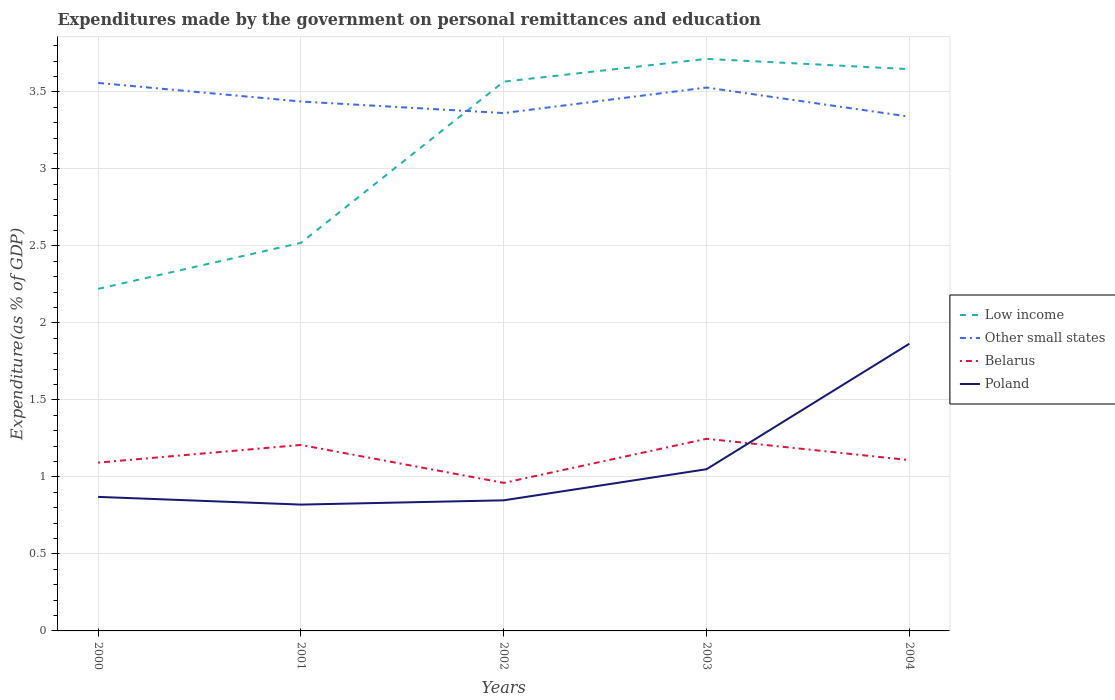How many different coloured lines are there?
Give a very brief answer. 4. Does the line corresponding to Other small states intersect with the line corresponding to Belarus?
Offer a very short reply. No. Is the number of lines equal to the number of legend labels?
Your response must be concise. Yes. Across all years, what is the maximum expenditures made by the government on personal remittances and education in Poland?
Offer a very short reply. 0.82. In which year was the expenditures made by the government on personal remittances and education in Poland maximum?
Provide a succinct answer. 2001. What is the total expenditures made by the government on personal remittances and education in Other small states in the graph?
Offer a terse response. 0.22. What is the difference between the highest and the second highest expenditures made by the government on personal remittances and education in Belarus?
Your answer should be compact. 0.29. What is the difference between the highest and the lowest expenditures made by the government on personal remittances and education in Poland?
Give a very brief answer. 1. How many lines are there?
Your answer should be compact. 4. How many years are there in the graph?
Your answer should be very brief. 5. What is the difference between two consecutive major ticks on the Y-axis?
Make the answer very short. 0.5. Where does the legend appear in the graph?
Provide a succinct answer. Center right. What is the title of the graph?
Give a very brief answer. Expenditures made by the government on personal remittances and education. Does "Morocco" appear as one of the legend labels in the graph?
Your answer should be compact. No. What is the label or title of the X-axis?
Offer a terse response. Years. What is the label or title of the Y-axis?
Keep it short and to the point. Expenditure(as % of GDP). What is the Expenditure(as % of GDP) in Low income in 2000?
Give a very brief answer. 2.22. What is the Expenditure(as % of GDP) of Other small states in 2000?
Offer a very short reply. 3.56. What is the Expenditure(as % of GDP) of Belarus in 2000?
Give a very brief answer. 1.09. What is the Expenditure(as % of GDP) in Poland in 2000?
Your response must be concise. 0.87. What is the Expenditure(as % of GDP) in Low income in 2001?
Make the answer very short. 2.52. What is the Expenditure(as % of GDP) of Other small states in 2001?
Make the answer very short. 3.44. What is the Expenditure(as % of GDP) in Belarus in 2001?
Your answer should be compact. 1.21. What is the Expenditure(as % of GDP) in Poland in 2001?
Ensure brevity in your answer.  0.82. What is the Expenditure(as % of GDP) in Low income in 2002?
Your answer should be compact. 3.57. What is the Expenditure(as % of GDP) in Other small states in 2002?
Your response must be concise. 3.36. What is the Expenditure(as % of GDP) in Belarus in 2002?
Your answer should be very brief. 0.96. What is the Expenditure(as % of GDP) of Poland in 2002?
Your answer should be very brief. 0.85. What is the Expenditure(as % of GDP) in Low income in 2003?
Your response must be concise. 3.71. What is the Expenditure(as % of GDP) in Other small states in 2003?
Offer a very short reply. 3.53. What is the Expenditure(as % of GDP) in Belarus in 2003?
Your answer should be very brief. 1.25. What is the Expenditure(as % of GDP) of Poland in 2003?
Offer a terse response. 1.05. What is the Expenditure(as % of GDP) in Low income in 2004?
Give a very brief answer. 3.65. What is the Expenditure(as % of GDP) of Other small states in 2004?
Your response must be concise. 3.34. What is the Expenditure(as % of GDP) in Belarus in 2004?
Make the answer very short. 1.11. What is the Expenditure(as % of GDP) in Poland in 2004?
Ensure brevity in your answer.  1.86. Across all years, what is the maximum Expenditure(as % of GDP) in Low income?
Offer a terse response. 3.71. Across all years, what is the maximum Expenditure(as % of GDP) in Other small states?
Your answer should be compact. 3.56. Across all years, what is the maximum Expenditure(as % of GDP) of Belarus?
Make the answer very short. 1.25. Across all years, what is the maximum Expenditure(as % of GDP) of Poland?
Keep it short and to the point. 1.86. Across all years, what is the minimum Expenditure(as % of GDP) in Low income?
Provide a short and direct response. 2.22. Across all years, what is the minimum Expenditure(as % of GDP) of Other small states?
Your answer should be very brief. 3.34. Across all years, what is the minimum Expenditure(as % of GDP) in Belarus?
Offer a very short reply. 0.96. Across all years, what is the minimum Expenditure(as % of GDP) in Poland?
Your answer should be compact. 0.82. What is the total Expenditure(as % of GDP) in Low income in the graph?
Your answer should be very brief. 15.67. What is the total Expenditure(as % of GDP) of Other small states in the graph?
Provide a short and direct response. 17.23. What is the total Expenditure(as % of GDP) in Belarus in the graph?
Your answer should be very brief. 5.62. What is the total Expenditure(as % of GDP) in Poland in the graph?
Provide a short and direct response. 5.45. What is the difference between the Expenditure(as % of GDP) in Low income in 2000 and that in 2001?
Your answer should be very brief. -0.3. What is the difference between the Expenditure(as % of GDP) of Other small states in 2000 and that in 2001?
Ensure brevity in your answer.  0.12. What is the difference between the Expenditure(as % of GDP) of Belarus in 2000 and that in 2001?
Your answer should be very brief. -0.11. What is the difference between the Expenditure(as % of GDP) in Low income in 2000 and that in 2002?
Make the answer very short. -1.35. What is the difference between the Expenditure(as % of GDP) in Other small states in 2000 and that in 2002?
Provide a succinct answer. 0.2. What is the difference between the Expenditure(as % of GDP) in Belarus in 2000 and that in 2002?
Offer a very short reply. 0.13. What is the difference between the Expenditure(as % of GDP) in Poland in 2000 and that in 2002?
Offer a very short reply. 0.02. What is the difference between the Expenditure(as % of GDP) in Low income in 2000 and that in 2003?
Your response must be concise. -1.49. What is the difference between the Expenditure(as % of GDP) in Other small states in 2000 and that in 2003?
Provide a short and direct response. 0.03. What is the difference between the Expenditure(as % of GDP) of Belarus in 2000 and that in 2003?
Provide a short and direct response. -0.15. What is the difference between the Expenditure(as % of GDP) of Poland in 2000 and that in 2003?
Your answer should be very brief. -0.18. What is the difference between the Expenditure(as % of GDP) in Low income in 2000 and that in 2004?
Your response must be concise. -1.43. What is the difference between the Expenditure(as % of GDP) of Other small states in 2000 and that in 2004?
Provide a succinct answer. 0.22. What is the difference between the Expenditure(as % of GDP) of Belarus in 2000 and that in 2004?
Make the answer very short. -0.02. What is the difference between the Expenditure(as % of GDP) in Poland in 2000 and that in 2004?
Give a very brief answer. -0.99. What is the difference between the Expenditure(as % of GDP) in Low income in 2001 and that in 2002?
Your answer should be very brief. -1.05. What is the difference between the Expenditure(as % of GDP) of Other small states in 2001 and that in 2002?
Provide a short and direct response. 0.08. What is the difference between the Expenditure(as % of GDP) in Belarus in 2001 and that in 2002?
Your response must be concise. 0.25. What is the difference between the Expenditure(as % of GDP) of Poland in 2001 and that in 2002?
Your answer should be very brief. -0.03. What is the difference between the Expenditure(as % of GDP) of Low income in 2001 and that in 2003?
Make the answer very short. -1.19. What is the difference between the Expenditure(as % of GDP) of Other small states in 2001 and that in 2003?
Ensure brevity in your answer.  -0.09. What is the difference between the Expenditure(as % of GDP) in Belarus in 2001 and that in 2003?
Give a very brief answer. -0.04. What is the difference between the Expenditure(as % of GDP) of Poland in 2001 and that in 2003?
Provide a short and direct response. -0.23. What is the difference between the Expenditure(as % of GDP) in Low income in 2001 and that in 2004?
Your answer should be compact. -1.13. What is the difference between the Expenditure(as % of GDP) in Other small states in 2001 and that in 2004?
Your answer should be compact. 0.1. What is the difference between the Expenditure(as % of GDP) of Belarus in 2001 and that in 2004?
Your answer should be compact. 0.1. What is the difference between the Expenditure(as % of GDP) in Poland in 2001 and that in 2004?
Your answer should be very brief. -1.04. What is the difference between the Expenditure(as % of GDP) of Low income in 2002 and that in 2003?
Make the answer very short. -0.15. What is the difference between the Expenditure(as % of GDP) of Other small states in 2002 and that in 2003?
Give a very brief answer. -0.17. What is the difference between the Expenditure(as % of GDP) in Belarus in 2002 and that in 2003?
Offer a very short reply. -0.29. What is the difference between the Expenditure(as % of GDP) in Poland in 2002 and that in 2003?
Your answer should be very brief. -0.2. What is the difference between the Expenditure(as % of GDP) of Low income in 2002 and that in 2004?
Offer a terse response. -0.08. What is the difference between the Expenditure(as % of GDP) in Other small states in 2002 and that in 2004?
Ensure brevity in your answer.  0.02. What is the difference between the Expenditure(as % of GDP) of Belarus in 2002 and that in 2004?
Give a very brief answer. -0.15. What is the difference between the Expenditure(as % of GDP) in Poland in 2002 and that in 2004?
Ensure brevity in your answer.  -1.02. What is the difference between the Expenditure(as % of GDP) of Low income in 2003 and that in 2004?
Provide a short and direct response. 0.07. What is the difference between the Expenditure(as % of GDP) of Other small states in 2003 and that in 2004?
Make the answer very short. 0.19. What is the difference between the Expenditure(as % of GDP) of Belarus in 2003 and that in 2004?
Offer a terse response. 0.14. What is the difference between the Expenditure(as % of GDP) in Poland in 2003 and that in 2004?
Provide a succinct answer. -0.81. What is the difference between the Expenditure(as % of GDP) of Low income in 2000 and the Expenditure(as % of GDP) of Other small states in 2001?
Keep it short and to the point. -1.22. What is the difference between the Expenditure(as % of GDP) of Low income in 2000 and the Expenditure(as % of GDP) of Belarus in 2001?
Your answer should be very brief. 1.01. What is the difference between the Expenditure(as % of GDP) of Low income in 2000 and the Expenditure(as % of GDP) of Poland in 2001?
Keep it short and to the point. 1.4. What is the difference between the Expenditure(as % of GDP) in Other small states in 2000 and the Expenditure(as % of GDP) in Belarus in 2001?
Give a very brief answer. 2.35. What is the difference between the Expenditure(as % of GDP) in Other small states in 2000 and the Expenditure(as % of GDP) in Poland in 2001?
Ensure brevity in your answer.  2.74. What is the difference between the Expenditure(as % of GDP) of Belarus in 2000 and the Expenditure(as % of GDP) of Poland in 2001?
Your response must be concise. 0.27. What is the difference between the Expenditure(as % of GDP) in Low income in 2000 and the Expenditure(as % of GDP) in Other small states in 2002?
Your response must be concise. -1.14. What is the difference between the Expenditure(as % of GDP) in Low income in 2000 and the Expenditure(as % of GDP) in Belarus in 2002?
Give a very brief answer. 1.26. What is the difference between the Expenditure(as % of GDP) in Low income in 2000 and the Expenditure(as % of GDP) in Poland in 2002?
Provide a succinct answer. 1.37. What is the difference between the Expenditure(as % of GDP) of Other small states in 2000 and the Expenditure(as % of GDP) of Belarus in 2002?
Ensure brevity in your answer.  2.6. What is the difference between the Expenditure(as % of GDP) of Other small states in 2000 and the Expenditure(as % of GDP) of Poland in 2002?
Keep it short and to the point. 2.71. What is the difference between the Expenditure(as % of GDP) in Belarus in 2000 and the Expenditure(as % of GDP) in Poland in 2002?
Your answer should be very brief. 0.24. What is the difference between the Expenditure(as % of GDP) in Low income in 2000 and the Expenditure(as % of GDP) in Other small states in 2003?
Keep it short and to the point. -1.31. What is the difference between the Expenditure(as % of GDP) in Low income in 2000 and the Expenditure(as % of GDP) in Belarus in 2003?
Your answer should be compact. 0.97. What is the difference between the Expenditure(as % of GDP) in Low income in 2000 and the Expenditure(as % of GDP) in Poland in 2003?
Provide a short and direct response. 1.17. What is the difference between the Expenditure(as % of GDP) in Other small states in 2000 and the Expenditure(as % of GDP) in Belarus in 2003?
Provide a succinct answer. 2.31. What is the difference between the Expenditure(as % of GDP) of Other small states in 2000 and the Expenditure(as % of GDP) of Poland in 2003?
Make the answer very short. 2.51. What is the difference between the Expenditure(as % of GDP) of Belarus in 2000 and the Expenditure(as % of GDP) of Poland in 2003?
Offer a very short reply. 0.04. What is the difference between the Expenditure(as % of GDP) of Low income in 2000 and the Expenditure(as % of GDP) of Other small states in 2004?
Provide a short and direct response. -1.12. What is the difference between the Expenditure(as % of GDP) in Low income in 2000 and the Expenditure(as % of GDP) in Belarus in 2004?
Provide a succinct answer. 1.11. What is the difference between the Expenditure(as % of GDP) of Low income in 2000 and the Expenditure(as % of GDP) of Poland in 2004?
Offer a terse response. 0.36. What is the difference between the Expenditure(as % of GDP) in Other small states in 2000 and the Expenditure(as % of GDP) in Belarus in 2004?
Your answer should be very brief. 2.45. What is the difference between the Expenditure(as % of GDP) of Other small states in 2000 and the Expenditure(as % of GDP) of Poland in 2004?
Your answer should be very brief. 1.69. What is the difference between the Expenditure(as % of GDP) in Belarus in 2000 and the Expenditure(as % of GDP) in Poland in 2004?
Offer a very short reply. -0.77. What is the difference between the Expenditure(as % of GDP) in Low income in 2001 and the Expenditure(as % of GDP) in Other small states in 2002?
Offer a very short reply. -0.84. What is the difference between the Expenditure(as % of GDP) in Low income in 2001 and the Expenditure(as % of GDP) in Belarus in 2002?
Your response must be concise. 1.56. What is the difference between the Expenditure(as % of GDP) of Low income in 2001 and the Expenditure(as % of GDP) of Poland in 2002?
Your answer should be very brief. 1.67. What is the difference between the Expenditure(as % of GDP) in Other small states in 2001 and the Expenditure(as % of GDP) in Belarus in 2002?
Keep it short and to the point. 2.48. What is the difference between the Expenditure(as % of GDP) of Other small states in 2001 and the Expenditure(as % of GDP) of Poland in 2002?
Your answer should be compact. 2.59. What is the difference between the Expenditure(as % of GDP) in Belarus in 2001 and the Expenditure(as % of GDP) in Poland in 2002?
Provide a short and direct response. 0.36. What is the difference between the Expenditure(as % of GDP) in Low income in 2001 and the Expenditure(as % of GDP) in Other small states in 2003?
Keep it short and to the point. -1.01. What is the difference between the Expenditure(as % of GDP) in Low income in 2001 and the Expenditure(as % of GDP) in Belarus in 2003?
Your answer should be compact. 1.27. What is the difference between the Expenditure(as % of GDP) in Low income in 2001 and the Expenditure(as % of GDP) in Poland in 2003?
Provide a succinct answer. 1.47. What is the difference between the Expenditure(as % of GDP) of Other small states in 2001 and the Expenditure(as % of GDP) of Belarus in 2003?
Provide a succinct answer. 2.19. What is the difference between the Expenditure(as % of GDP) in Other small states in 2001 and the Expenditure(as % of GDP) in Poland in 2003?
Provide a short and direct response. 2.39. What is the difference between the Expenditure(as % of GDP) of Belarus in 2001 and the Expenditure(as % of GDP) of Poland in 2003?
Offer a terse response. 0.16. What is the difference between the Expenditure(as % of GDP) of Low income in 2001 and the Expenditure(as % of GDP) of Other small states in 2004?
Your answer should be very brief. -0.82. What is the difference between the Expenditure(as % of GDP) in Low income in 2001 and the Expenditure(as % of GDP) in Belarus in 2004?
Provide a short and direct response. 1.41. What is the difference between the Expenditure(as % of GDP) in Low income in 2001 and the Expenditure(as % of GDP) in Poland in 2004?
Your answer should be compact. 0.66. What is the difference between the Expenditure(as % of GDP) of Other small states in 2001 and the Expenditure(as % of GDP) of Belarus in 2004?
Provide a succinct answer. 2.33. What is the difference between the Expenditure(as % of GDP) in Other small states in 2001 and the Expenditure(as % of GDP) in Poland in 2004?
Keep it short and to the point. 1.57. What is the difference between the Expenditure(as % of GDP) in Belarus in 2001 and the Expenditure(as % of GDP) in Poland in 2004?
Ensure brevity in your answer.  -0.66. What is the difference between the Expenditure(as % of GDP) of Low income in 2002 and the Expenditure(as % of GDP) of Other small states in 2003?
Your answer should be very brief. 0.04. What is the difference between the Expenditure(as % of GDP) of Low income in 2002 and the Expenditure(as % of GDP) of Belarus in 2003?
Ensure brevity in your answer.  2.32. What is the difference between the Expenditure(as % of GDP) of Low income in 2002 and the Expenditure(as % of GDP) of Poland in 2003?
Make the answer very short. 2.52. What is the difference between the Expenditure(as % of GDP) of Other small states in 2002 and the Expenditure(as % of GDP) of Belarus in 2003?
Give a very brief answer. 2.12. What is the difference between the Expenditure(as % of GDP) in Other small states in 2002 and the Expenditure(as % of GDP) in Poland in 2003?
Your response must be concise. 2.31. What is the difference between the Expenditure(as % of GDP) of Belarus in 2002 and the Expenditure(as % of GDP) of Poland in 2003?
Your response must be concise. -0.09. What is the difference between the Expenditure(as % of GDP) of Low income in 2002 and the Expenditure(as % of GDP) of Other small states in 2004?
Ensure brevity in your answer.  0.23. What is the difference between the Expenditure(as % of GDP) in Low income in 2002 and the Expenditure(as % of GDP) in Belarus in 2004?
Offer a terse response. 2.46. What is the difference between the Expenditure(as % of GDP) of Low income in 2002 and the Expenditure(as % of GDP) of Poland in 2004?
Your answer should be very brief. 1.7. What is the difference between the Expenditure(as % of GDP) in Other small states in 2002 and the Expenditure(as % of GDP) in Belarus in 2004?
Make the answer very short. 2.25. What is the difference between the Expenditure(as % of GDP) of Other small states in 2002 and the Expenditure(as % of GDP) of Poland in 2004?
Provide a succinct answer. 1.5. What is the difference between the Expenditure(as % of GDP) of Belarus in 2002 and the Expenditure(as % of GDP) of Poland in 2004?
Your response must be concise. -0.9. What is the difference between the Expenditure(as % of GDP) in Low income in 2003 and the Expenditure(as % of GDP) in Other small states in 2004?
Ensure brevity in your answer.  0.38. What is the difference between the Expenditure(as % of GDP) of Low income in 2003 and the Expenditure(as % of GDP) of Belarus in 2004?
Your response must be concise. 2.61. What is the difference between the Expenditure(as % of GDP) in Low income in 2003 and the Expenditure(as % of GDP) in Poland in 2004?
Offer a very short reply. 1.85. What is the difference between the Expenditure(as % of GDP) of Other small states in 2003 and the Expenditure(as % of GDP) of Belarus in 2004?
Offer a terse response. 2.42. What is the difference between the Expenditure(as % of GDP) of Other small states in 2003 and the Expenditure(as % of GDP) of Poland in 2004?
Offer a terse response. 1.66. What is the difference between the Expenditure(as % of GDP) of Belarus in 2003 and the Expenditure(as % of GDP) of Poland in 2004?
Your response must be concise. -0.62. What is the average Expenditure(as % of GDP) in Low income per year?
Provide a short and direct response. 3.13. What is the average Expenditure(as % of GDP) of Other small states per year?
Offer a terse response. 3.45. What is the average Expenditure(as % of GDP) of Belarus per year?
Provide a succinct answer. 1.12. What is the average Expenditure(as % of GDP) of Poland per year?
Your answer should be very brief. 1.09. In the year 2000, what is the difference between the Expenditure(as % of GDP) in Low income and Expenditure(as % of GDP) in Other small states?
Your answer should be compact. -1.34. In the year 2000, what is the difference between the Expenditure(as % of GDP) in Low income and Expenditure(as % of GDP) in Belarus?
Your response must be concise. 1.13. In the year 2000, what is the difference between the Expenditure(as % of GDP) in Low income and Expenditure(as % of GDP) in Poland?
Provide a short and direct response. 1.35. In the year 2000, what is the difference between the Expenditure(as % of GDP) in Other small states and Expenditure(as % of GDP) in Belarus?
Offer a very short reply. 2.47. In the year 2000, what is the difference between the Expenditure(as % of GDP) in Other small states and Expenditure(as % of GDP) in Poland?
Keep it short and to the point. 2.69. In the year 2000, what is the difference between the Expenditure(as % of GDP) of Belarus and Expenditure(as % of GDP) of Poland?
Give a very brief answer. 0.22. In the year 2001, what is the difference between the Expenditure(as % of GDP) in Low income and Expenditure(as % of GDP) in Other small states?
Keep it short and to the point. -0.92. In the year 2001, what is the difference between the Expenditure(as % of GDP) in Low income and Expenditure(as % of GDP) in Belarus?
Your answer should be compact. 1.31. In the year 2001, what is the difference between the Expenditure(as % of GDP) in Low income and Expenditure(as % of GDP) in Poland?
Keep it short and to the point. 1.7. In the year 2001, what is the difference between the Expenditure(as % of GDP) in Other small states and Expenditure(as % of GDP) in Belarus?
Keep it short and to the point. 2.23. In the year 2001, what is the difference between the Expenditure(as % of GDP) of Other small states and Expenditure(as % of GDP) of Poland?
Ensure brevity in your answer.  2.62. In the year 2001, what is the difference between the Expenditure(as % of GDP) in Belarus and Expenditure(as % of GDP) in Poland?
Provide a succinct answer. 0.39. In the year 2002, what is the difference between the Expenditure(as % of GDP) of Low income and Expenditure(as % of GDP) of Other small states?
Give a very brief answer. 0.2. In the year 2002, what is the difference between the Expenditure(as % of GDP) in Low income and Expenditure(as % of GDP) in Belarus?
Offer a terse response. 2.61. In the year 2002, what is the difference between the Expenditure(as % of GDP) of Low income and Expenditure(as % of GDP) of Poland?
Provide a short and direct response. 2.72. In the year 2002, what is the difference between the Expenditure(as % of GDP) in Other small states and Expenditure(as % of GDP) in Belarus?
Your answer should be compact. 2.4. In the year 2002, what is the difference between the Expenditure(as % of GDP) of Other small states and Expenditure(as % of GDP) of Poland?
Provide a succinct answer. 2.51. In the year 2002, what is the difference between the Expenditure(as % of GDP) of Belarus and Expenditure(as % of GDP) of Poland?
Ensure brevity in your answer.  0.11. In the year 2003, what is the difference between the Expenditure(as % of GDP) in Low income and Expenditure(as % of GDP) in Other small states?
Give a very brief answer. 0.19. In the year 2003, what is the difference between the Expenditure(as % of GDP) of Low income and Expenditure(as % of GDP) of Belarus?
Give a very brief answer. 2.47. In the year 2003, what is the difference between the Expenditure(as % of GDP) in Low income and Expenditure(as % of GDP) in Poland?
Make the answer very short. 2.66. In the year 2003, what is the difference between the Expenditure(as % of GDP) of Other small states and Expenditure(as % of GDP) of Belarus?
Your response must be concise. 2.28. In the year 2003, what is the difference between the Expenditure(as % of GDP) of Other small states and Expenditure(as % of GDP) of Poland?
Give a very brief answer. 2.48. In the year 2003, what is the difference between the Expenditure(as % of GDP) in Belarus and Expenditure(as % of GDP) in Poland?
Offer a very short reply. 0.2. In the year 2004, what is the difference between the Expenditure(as % of GDP) of Low income and Expenditure(as % of GDP) of Other small states?
Keep it short and to the point. 0.31. In the year 2004, what is the difference between the Expenditure(as % of GDP) of Low income and Expenditure(as % of GDP) of Belarus?
Make the answer very short. 2.54. In the year 2004, what is the difference between the Expenditure(as % of GDP) in Low income and Expenditure(as % of GDP) in Poland?
Make the answer very short. 1.78. In the year 2004, what is the difference between the Expenditure(as % of GDP) in Other small states and Expenditure(as % of GDP) in Belarus?
Provide a short and direct response. 2.23. In the year 2004, what is the difference between the Expenditure(as % of GDP) of Other small states and Expenditure(as % of GDP) of Poland?
Your answer should be very brief. 1.47. In the year 2004, what is the difference between the Expenditure(as % of GDP) in Belarus and Expenditure(as % of GDP) in Poland?
Offer a terse response. -0.76. What is the ratio of the Expenditure(as % of GDP) of Low income in 2000 to that in 2001?
Offer a terse response. 0.88. What is the ratio of the Expenditure(as % of GDP) in Other small states in 2000 to that in 2001?
Give a very brief answer. 1.04. What is the ratio of the Expenditure(as % of GDP) of Belarus in 2000 to that in 2001?
Provide a succinct answer. 0.91. What is the ratio of the Expenditure(as % of GDP) in Poland in 2000 to that in 2001?
Your answer should be very brief. 1.06. What is the ratio of the Expenditure(as % of GDP) of Low income in 2000 to that in 2002?
Offer a very short reply. 0.62. What is the ratio of the Expenditure(as % of GDP) of Other small states in 2000 to that in 2002?
Make the answer very short. 1.06. What is the ratio of the Expenditure(as % of GDP) of Belarus in 2000 to that in 2002?
Provide a succinct answer. 1.14. What is the ratio of the Expenditure(as % of GDP) in Poland in 2000 to that in 2002?
Provide a short and direct response. 1.03. What is the ratio of the Expenditure(as % of GDP) in Low income in 2000 to that in 2003?
Your answer should be very brief. 0.6. What is the ratio of the Expenditure(as % of GDP) in Other small states in 2000 to that in 2003?
Offer a very short reply. 1.01. What is the ratio of the Expenditure(as % of GDP) in Belarus in 2000 to that in 2003?
Provide a short and direct response. 0.88. What is the ratio of the Expenditure(as % of GDP) of Poland in 2000 to that in 2003?
Ensure brevity in your answer.  0.83. What is the ratio of the Expenditure(as % of GDP) in Low income in 2000 to that in 2004?
Your response must be concise. 0.61. What is the ratio of the Expenditure(as % of GDP) of Other small states in 2000 to that in 2004?
Your answer should be very brief. 1.07. What is the ratio of the Expenditure(as % of GDP) in Belarus in 2000 to that in 2004?
Offer a terse response. 0.99. What is the ratio of the Expenditure(as % of GDP) in Poland in 2000 to that in 2004?
Provide a short and direct response. 0.47. What is the ratio of the Expenditure(as % of GDP) in Low income in 2001 to that in 2002?
Provide a short and direct response. 0.71. What is the ratio of the Expenditure(as % of GDP) in Other small states in 2001 to that in 2002?
Your answer should be compact. 1.02. What is the ratio of the Expenditure(as % of GDP) of Belarus in 2001 to that in 2002?
Provide a succinct answer. 1.26. What is the ratio of the Expenditure(as % of GDP) in Poland in 2001 to that in 2002?
Provide a succinct answer. 0.97. What is the ratio of the Expenditure(as % of GDP) of Low income in 2001 to that in 2003?
Your answer should be very brief. 0.68. What is the ratio of the Expenditure(as % of GDP) of Other small states in 2001 to that in 2003?
Offer a terse response. 0.97. What is the ratio of the Expenditure(as % of GDP) of Belarus in 2001 to that in 2003?
Give a very brief answer. 0.97. What is the ratio of the Expenditure(as % of GDP) of Poland in 2001 to that in 2003?
Provide a succinct answer. 0.78. What is the ratio of the Expenditure(as % of GDP) in Low income in 2001 to that in 2004?
Keep it short and to the point. 0.69. What is the ratio of the Expenditure(as % of GDP) of Other small states in 2001 to that in 2004?
Provide a short and direct response. 1.03. What is the ratio of the Expenditure(as % of GDP) of Belarus in 2001 to that in 2004?
Your response must be concise. 1.09. What is the ratio of the Expenditure(as % of GDP) in Poland in 2001 to that in 2004?
Your answer should be compact. 0.44. What is the ratio of the Expenditure(as % of GDP) in Low income in 2002 to that in 2003?
Make the answer very short. 0.96. What is the ratio of the Expenditure(as % of GDP) in Other small states in 2002 to that in 2003?
Offer a very short reply. 0.95. What is the ratio of the Expenditure(as % of GDP) of Belarus in 2002 to that in 2003?
Make the answer very short. 0.77. What is the ratio of the Expenditure(as % of GDP) of Poland in 2002 to that in 2003?
Give a very brief answer. 0.81. What is the ratio of the Expenditure(as % of GDP) of Low income in 2002 to that in 2004?
Offer a very short reply. 0.98. What is the ratio of the Expenditure(as % of GDP) in Belarus in 2002 to that in 2004?
Keep it short and to the point. 0.87. What is the ratio of the Expenditure(as % of GDP) in Poland in 2002 to that in 2004?
Ensure brevity in your answer.  0.45. What is the ratio of the Expenditure(as % of GDP) in Low income in 2003 to that in 2004?
Ensure brevity in your answer.  1.02. What is the ratio of the Expenditure(as % of GDP) in Other small states in 2003 to that in 2004?
Offer a terse response. 1.06. What is the ratio of the Expenditure(as % of GDP) in Belarus in 2003 to that in 2004?
Provide a short and direct response. 1.12. What is the ratio of the Expenditure(as % of GDP) of Poland in 2003 to that in 2004?
Your answer should be very brief. 0.56. What is the difference between the highest and the second highest Expenditure(as % of GDP) of Low income?
Your response must be concise. 0.07. What is the difference between the highest and the second highest Expenditure(as % of GDP) of Other small states?
Your answer should be compact. 0.03. What is the difference between the highest and the second highest Expenditure(as % of GDP) of Poland?
Provide a short and direct response. 0.81. What is the difference between the highest and the lowest Expenditure(as % of GDP) in Low income?
Offer a terse response. 1.49. What is the difference between the highest and the lowest Expenditure(as % of GDP) in Other small states?
Offer a terse response. 0.22. What is the difference between the highest and the lowest Expenditure(as % of GDP) of Belarus?
Your answer should be very brief. 0.29. What is the difference between the highest and the lowest Expenditure(as % of GDP) in Poland?
Give a very brief answer. 1.04. 